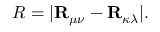<formula> <loc_0><loc_0><loc_500><loc_500>R = | R _ { \mu \nu } - R _ { \kappa \lambda } | .</formula> 